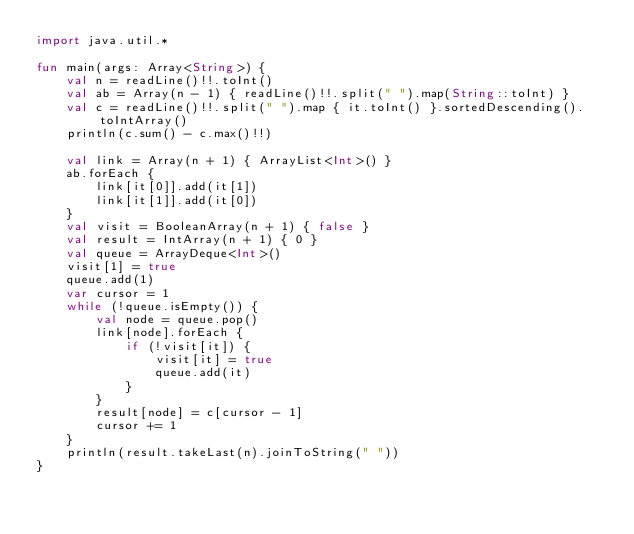Convert code to text. <code><loc_0><loc_0><loc_500><loc_500><_Kotlin_>import java.util.*

fun main(args: Array<String>) {
    val n = readLine()!!.toInt()
    val ab = Array(n - 1) { readLine()!!.split(" ").map(String::toInt) }
    val c = readLine()!!.split(" ").map { it.toInt() }.sortedDescending().toIntArray()
    println(c.sum() - c.max()!!)

    val link = Array(n + 1) { ArrayList<Int>() }
    ab.forEach {
        link[it[0]].add(it[1])
        link[it[1]].add(it[0])
    }
    val visit = BooleanArray(n + 1) { false }
    val result = IntArray(n + 1) { 0 }
    val queue = ArrayDeque<Int>()
    visit[1] = true
    queue.add(1)
    var cursor = 1
    while (!queue.isEmpty()) {
        val node = queue.pop()
        link[node].forEach {
            if (!visit[it]) {
                visit[it] = true
                queue.add(it)
            }
        }
        result[node] = c[cursor - 1]
        cursor += 1
    }
    println(result.takeLast(n).joinToString(" "))
}</code> 